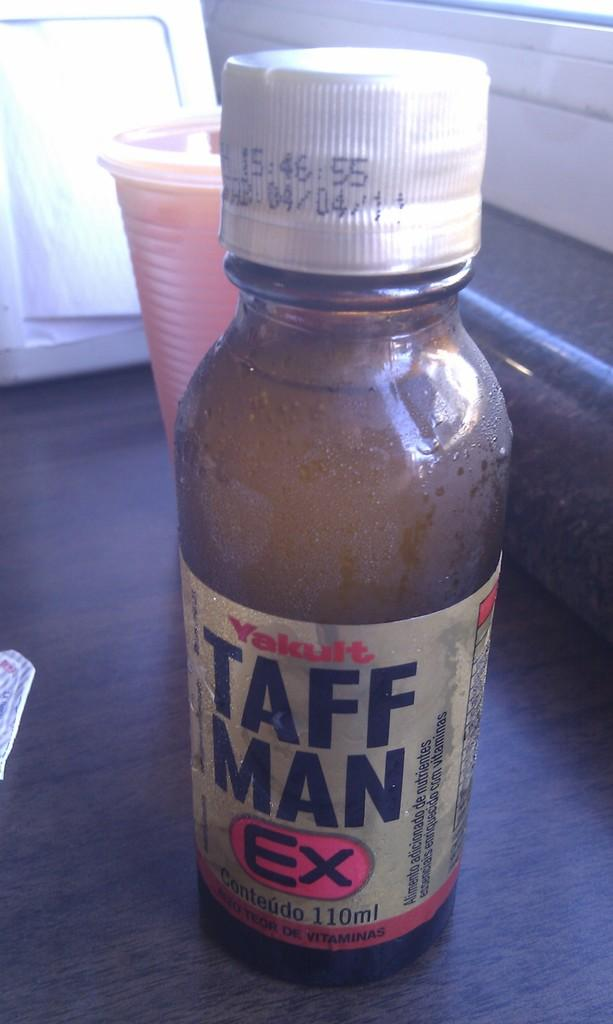<image>
Offer a succinct explanation of the picture presented. A bottle of Taff Man Ex in front of a cup. 